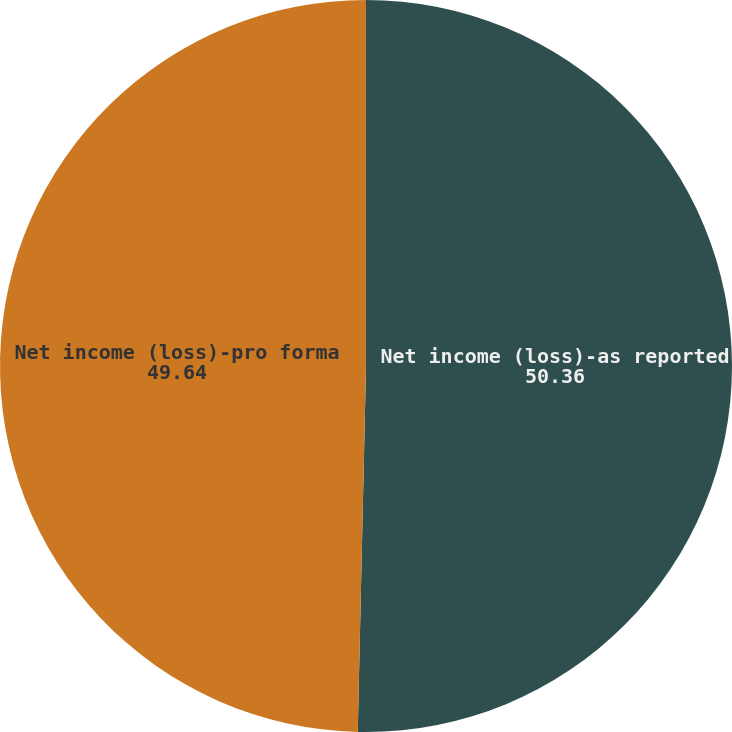<chart> <loc_0><loc_0><loc_500><loc_500><pie_chart><fcel>Net income (loss)-as reported<fcel>Net income (loss)-pro forma<nl><fcel>50.36%<fcel>49.64%<nl></chart> 